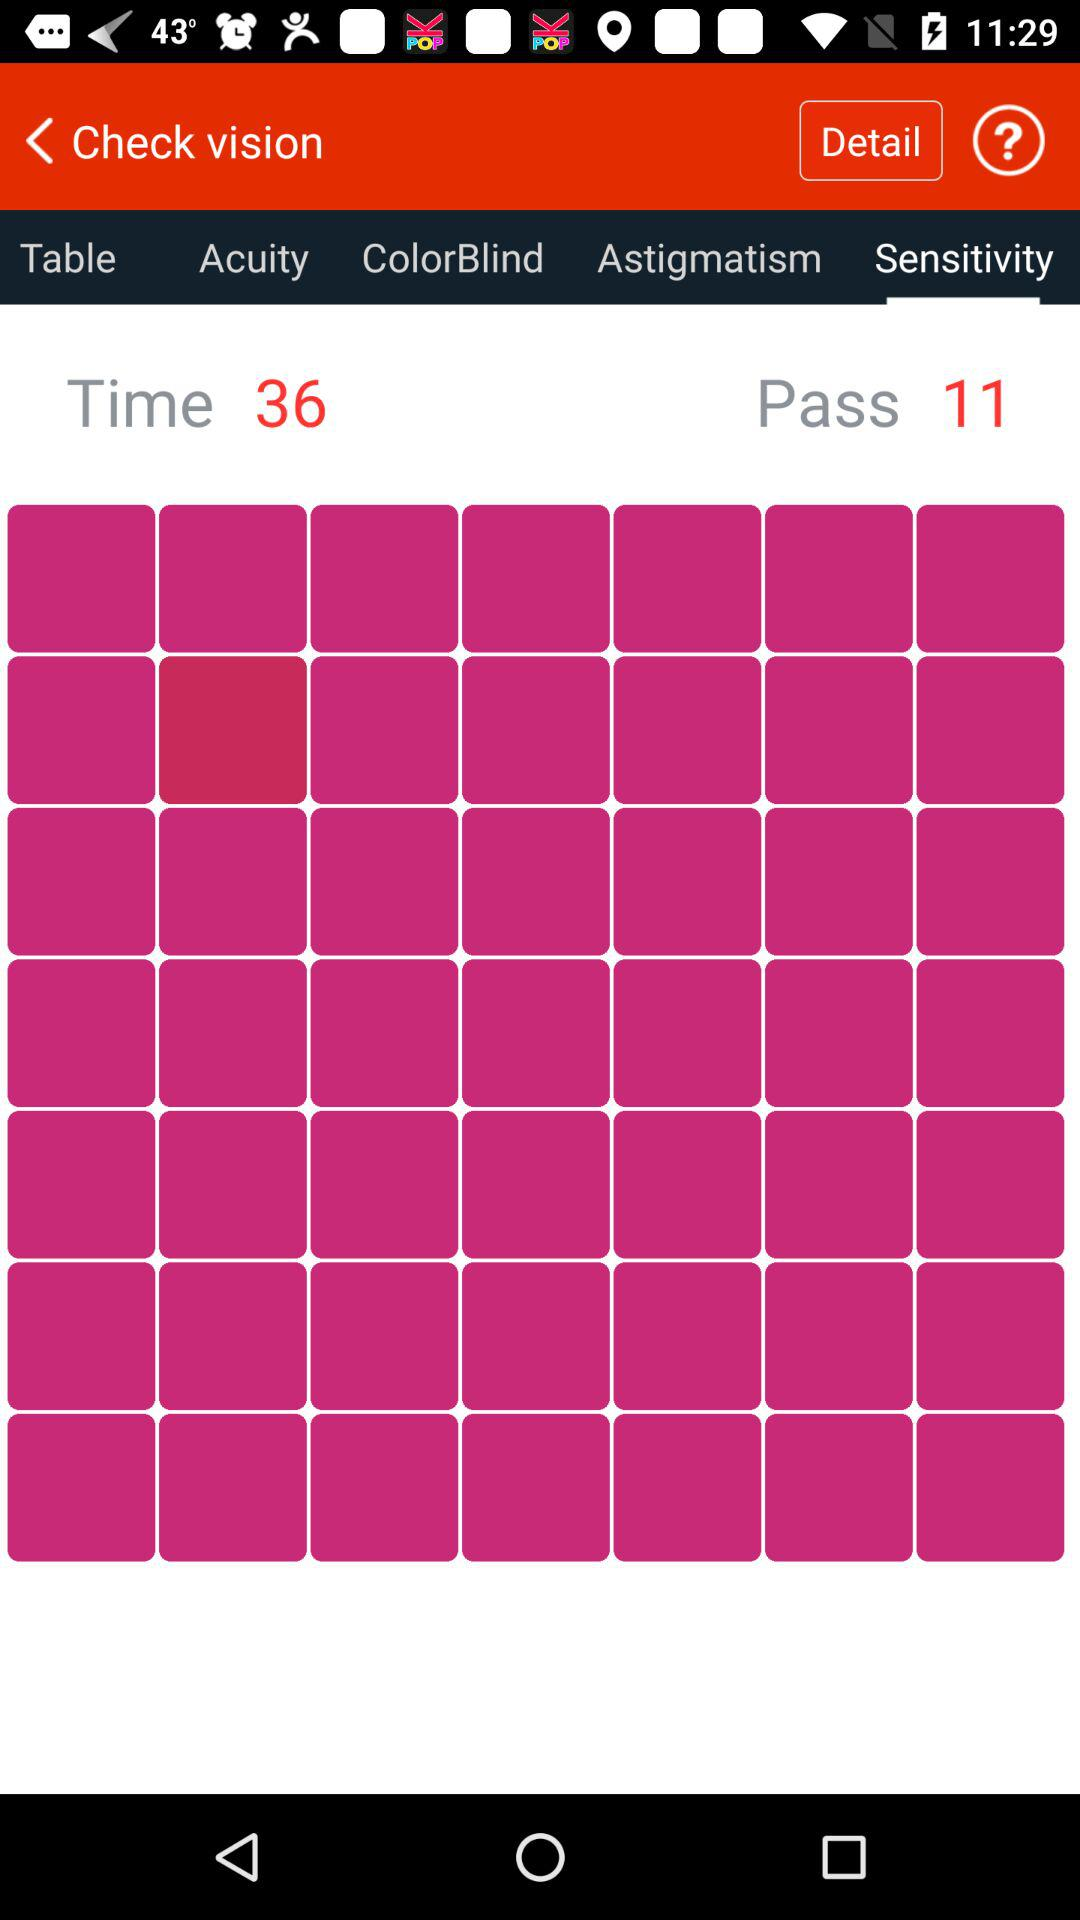What is the selected tab? The selected tab is "Sensitivity". 